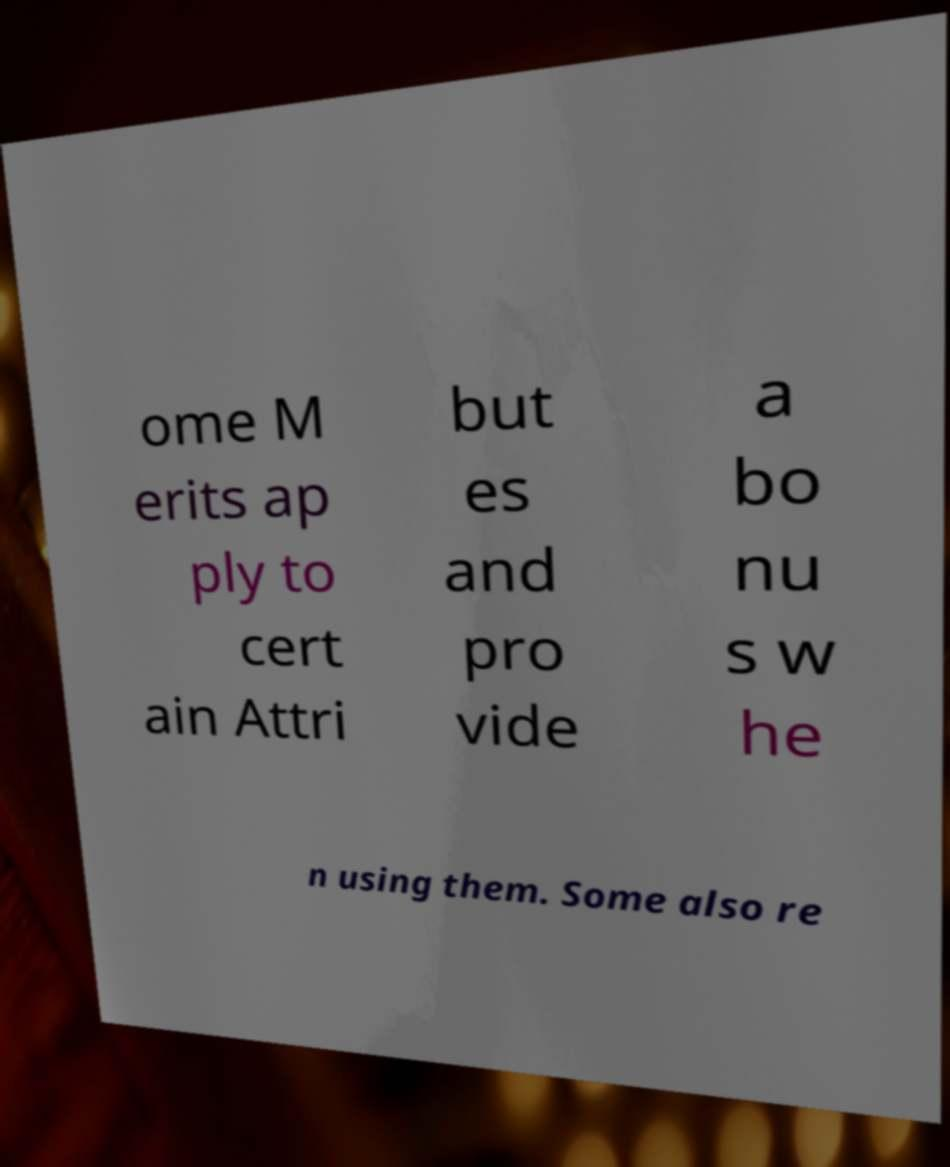What messages or text are displayed in this image? I need them in a readable, typed format. ome M erits ap ply to cert ain Attri but es and pro vide a bo nu s w he n using them. Some also re 